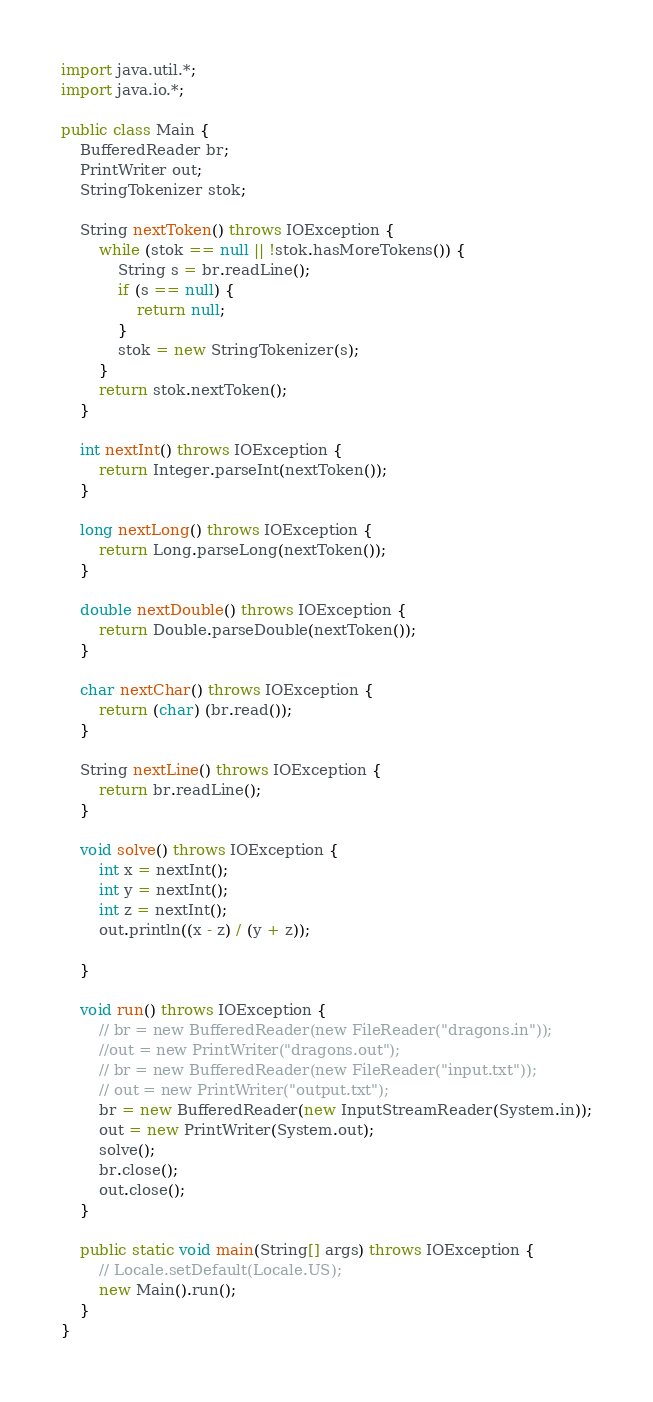Convert code to text. <code><loc_0><loc_0><loc_500><loc_500><_Java_>import java.util.*;
import java.io.*;

public class Main {
    BufferedReader br;
    PrintWriter out;
    StringTokenizer stok;

    String nextToken() throws IOException {
        while (stok == null || !stok.hasMoreTokens()) {
            String s = br.readLine();
            if (s == null) {
                return null;
            }
            stok = new StringTokenizer(s);
        }
        return stok.nextToken();
    }

    int nextInt() throws IOException {
        return Integer.parseInt(nextToken());
    }

    long nextLong() throws IOException {
        return Long.parseLong(nextToken());
    }

    double nextDouble() throws IOException {
        return Double.parseDouble(nextToken());
    }

    char nextChar() throws IOException {
        return (char) (br.read());
    }

    String nextLine() throws IOException {
        return br.readLine();
    }

    void solve() throws IOException {
        int x = nextInt();
        int y = nextInt();
        int z = nextInt();
        out.println((x - z) / (y + z));

    }

    void run() throws IOException {
        // br = new BufferedReader(new FileReader("dragons.in"));
        //out = new PrintWriter("dragons.out");
        // br = new BufferedReader(new FileReader("input.txt"));
        // out = new PrintWriter("output.txt");
        br = new BufferedReader(new InputStreamReader(System.in));
        out = new PrintWriter(System.out);
        solve();
        br.close();
        out.close();
    }

    public static void main(String[] args) throws IOException {
        // Locale.setDefault(Locale.US);
        new Main().run();
    }
}</code> 